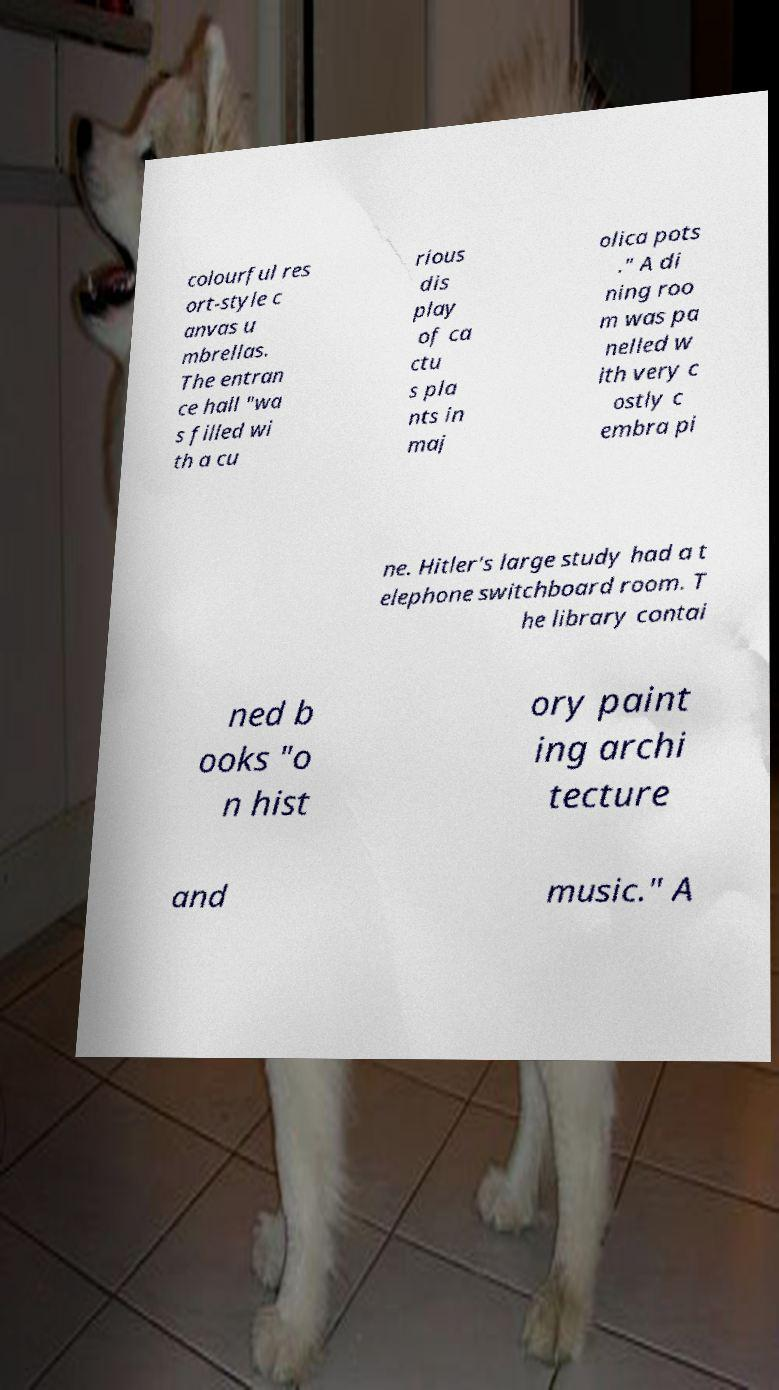For documentation purposes, I need the text within this image transcribed. Could you provide that? colourful res ort-style c anvas u mbrellas. The entran ce hall "wa s filled wi th a cu rious dis play of ca ctu s pla nts in maj olica pots ." A di ning roo m was pa nelled w ith very c ostly c embra pi ne. Hitler's large study had a t elephone switchboard room. T he library contai ned b ooks "o n hist ory paint ing archi tecture and music." A 